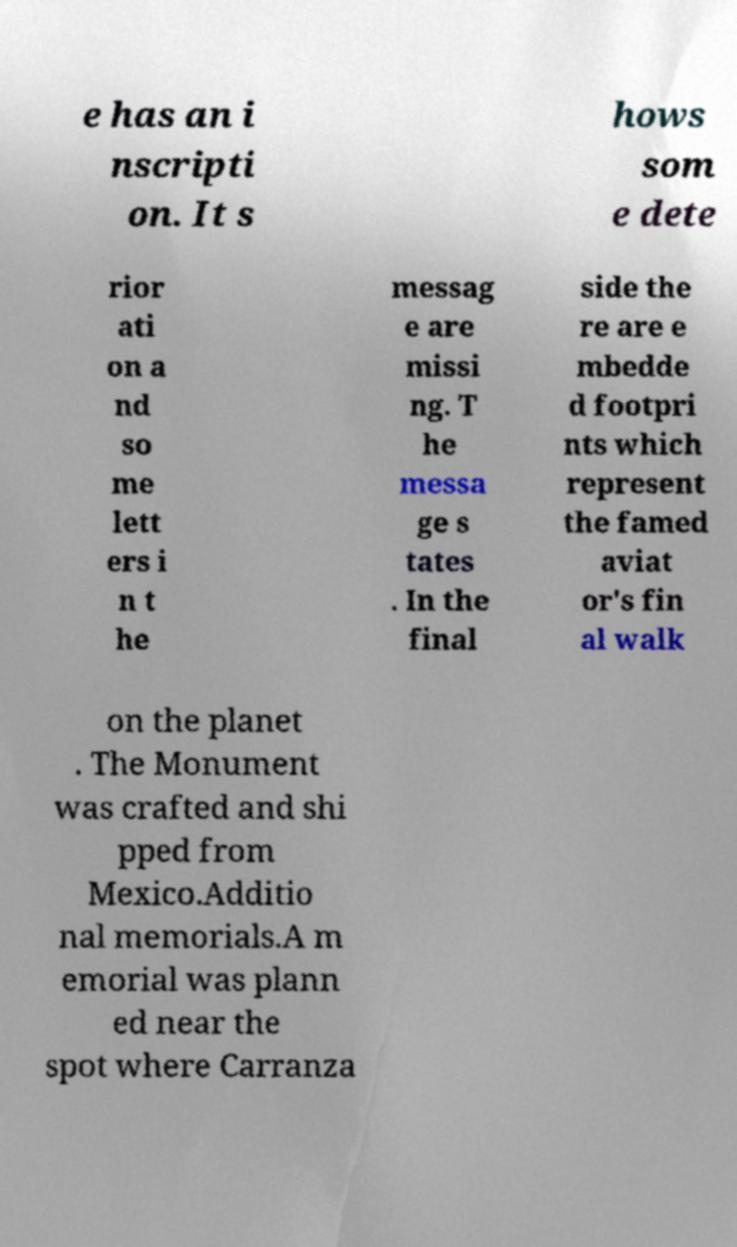There's text embedded in this image that I need extracted. Can you transcribe it verbatim? e has an i nscripti on. It s hows som e dete rior ati on a nd so me lett ers i n t he messag e are missi ng. T he messa ge s tates . In the final side the re are e mbedde d footpri nts which represent the famed aviat or's fin al walk on the planet . The Monument was crafted and shi pped from Mexico.Additio nal memorials.A m emorial was plann ed near the spot where Carranza 